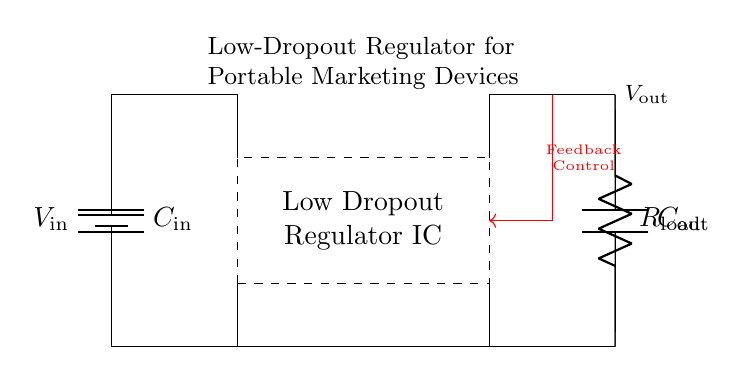What type of capacitor is used in this circuit? The circuit diagram shows an input capacitor labeled as C in, which is often used for filtering and stabilization, and an output capacitor labeled as C out for smoothing the output voltage.
Answer: Capacitor What is the role of the low dropout regulator in this circuit? The low dropout regulator, as indicated in the circuit, is responsible for maintaining a constant output voltage even when the input voltage varies and is particularly important for battery-operated devices to maximize efficiency.
Answer: Voltage regulation What is the output voltage denoted as in this circuit? The output voltage is labeled as V out, representing the regulated voltage provided to the load connected to the output of the low dropout regulator.
Answer: V out How many resistive components are present in this circuit? The circuit contains one resistive component indicated as R load, which represents the load connected to the output of the regulator, allowing us to analyze the load's characteristics.
Answer: One What is the significance of the feedback control in this circuit? The feedback control, indicated by the red arrow in the diagram, is essential for the stability and regulation of the output voltage, as it adjusts the operation of the low dropout regulator based on the output voltage conditions.
Answer: Stability What can be said about the input voltage in relation to the load? The input voltage, labeled as V in, must be higher than the output voltage due to the operational nature of the low dropout regulator, ensuring it functions correctly to supply power to the load.
Answer: Higher 